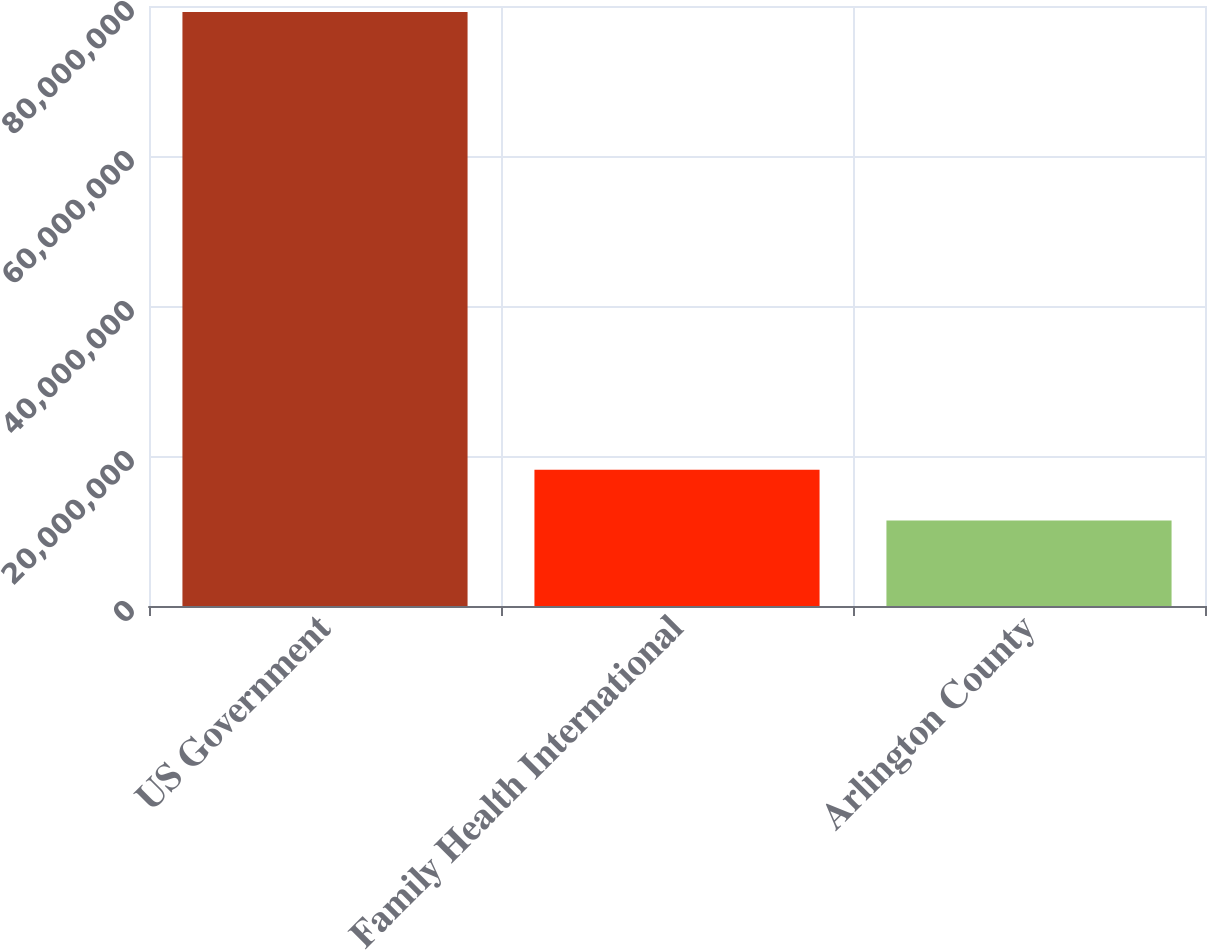Convert chart to OTSL. <chart><loc_0><loc_0><loc_500><loc_500><bar_chart><fcel>US Government<fcel>Family Health International<fcel>Arlington County<nl><fcel>7.9185e+07<fcel>1.81677e+07<fcel>1.1388e+07<nl></chart> 